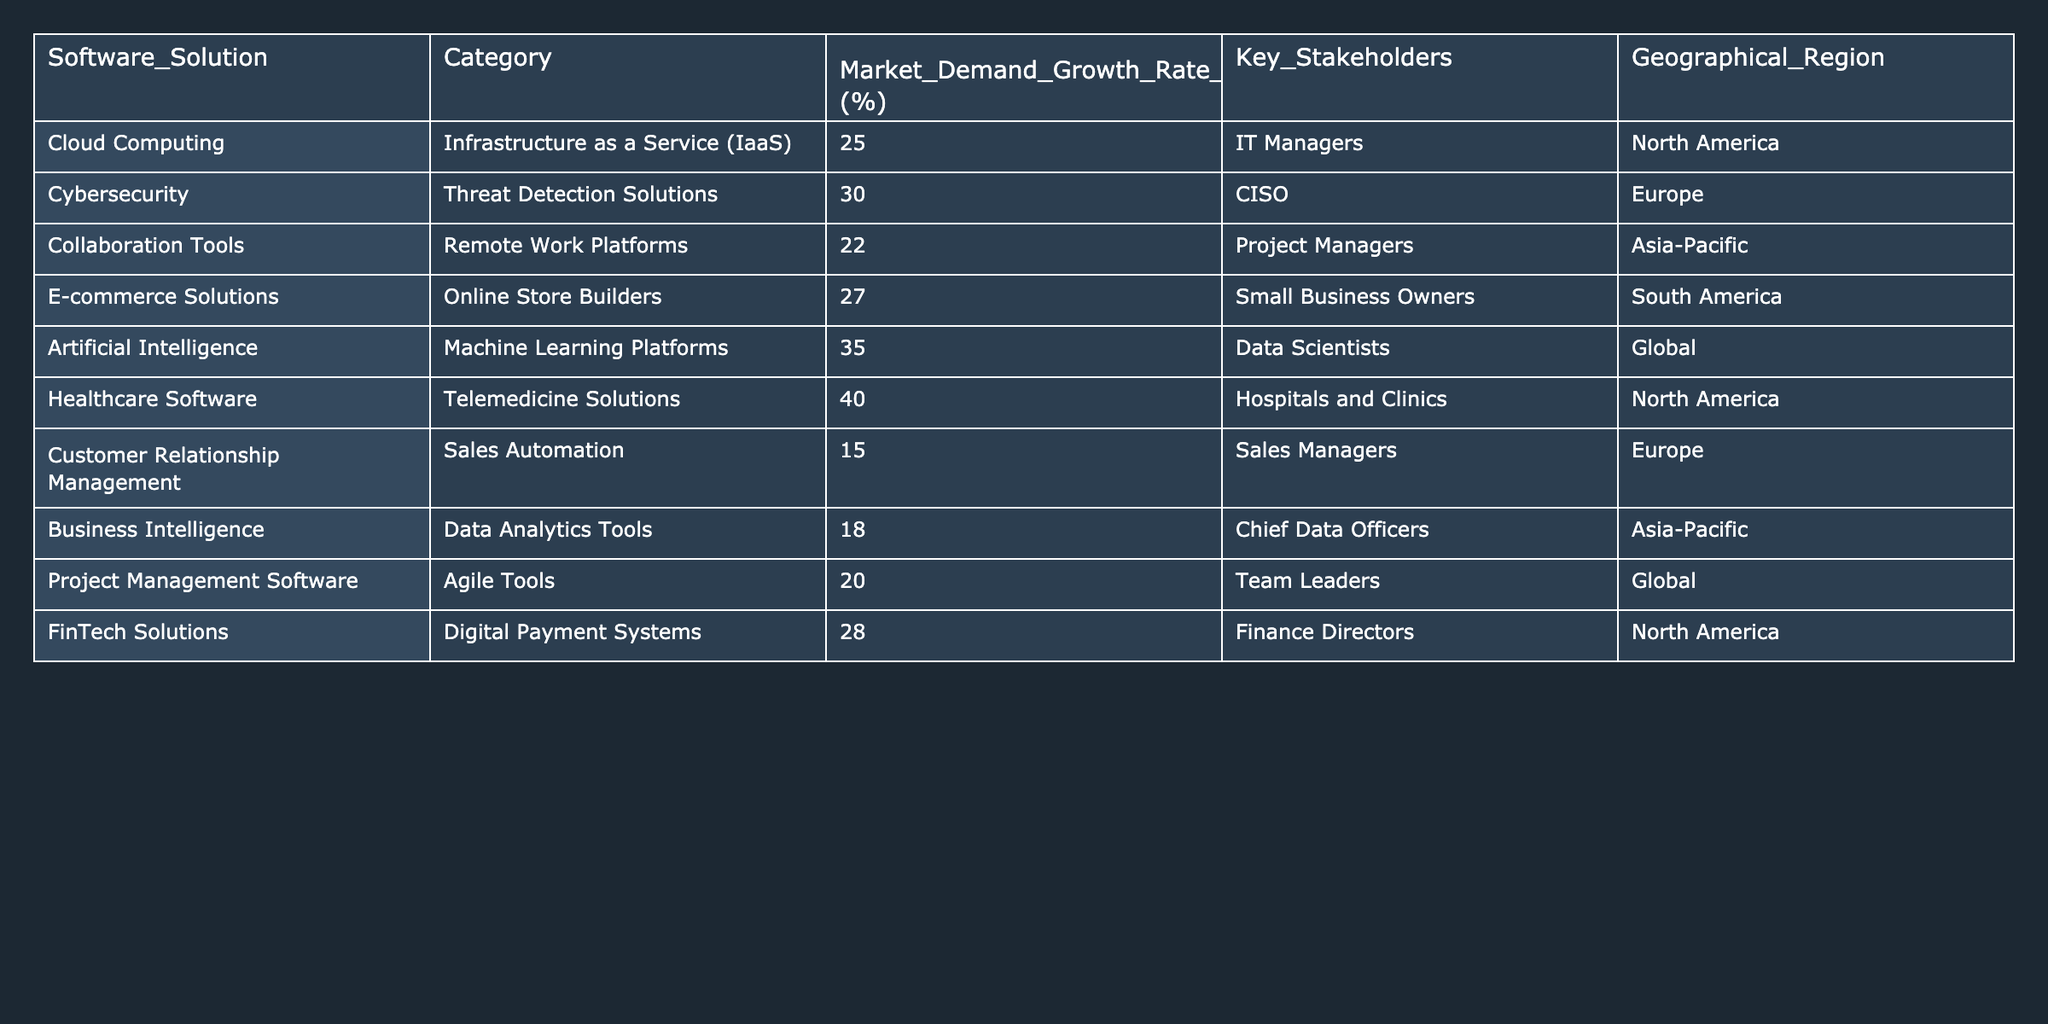What is the software solution with the highest market demand growth rate in 2023? By examining the "Market Demand Growth Rate 2023 (%)" column, I identify the value that stands out the most, which is 40%, corresponding to "Healthcare Software" in the table.
Answer: Healthcare Software Which geographical region shows the highest demand growth for cybersecurity solutions? Looking at the table, "Cybersecurity, Threat Detection Solutions" has a growth rate of 30%, and it is categorized under Europe, indicating that Europe has the highest demand for this specific software solution.
Answer: Europe How many software solutions have a growth rate of over 25%? I count the rows with growth rates of 25% or higher: "Cloud Computing" (25%), "Cybersecurity" (30%), "E-commerce Solutions" (27%), "Artificial Intelligence" (35%), "Healthcare Software" (40%), and "FinTech Solutions" (28%). That gives a total of six solutions.
Answer: 6 What is the average market demand growth rate for software solutions in North America? The software solutions in North America are "Cloud Computing" (25%), "Healthcare Software" (40%), and "FinTech Solutions" (28%). To find the average, I add 25 + 40 + 28 = 93 and divide by 3, resulting in an average growth rate of 31%.
Answer: 31% Is there any software solution in the table categorized under healthcare? By reviewing the "Category" column, I see "Healthcare Software" clearly listed, confirming that healthcare solutions are represented in the table.
Answer: Yes Which category has the lowest growth rate, and what is that rate? I inspect the "Market Demand Growth Rate 2023 (%)" column, finding "Customer Relationship Management" at 15%, which is the lowest growth rate among all solutions listed.
Answer: 15% Compare the growth rates of collaboration tools and project management software. Which has the higher growth rate? In the table, the growth rate for "Collaboration Tools" (22%) is compared with "Project Management Software" (20%). Since 22% is greater than 20%, collaboration tools have the higher growth rate.
Answer: Collaboration Tools What percentage growth does the software solution aimed at hospitals and clinics have? I locate "Healthcare Software" under the "Software Solution" column and find its growth rate of 40% directly associated with hospitals and clinics in the "Key Stakeholders" column.
Answer: 40% Are there any solutions in the table with a growth rate below 20%? I review the "Market Demand Growth Rate 2023 (%)" column and find "Customer Relationship Management" at 15% which is indeed below 20%, confirming that there is at least one solution that meets this criterion.
Answer: Yes Calculate the total market demand growth rate for all solutions listed in South America and Asia-Pacific. The relevant growth rates for "E-commerce Solutions" (South America) at 27% and "Business Intelligence" (Asia-Pacific) at 18% are added together to find 27 + 18 = 45%.
Answer: 45% 